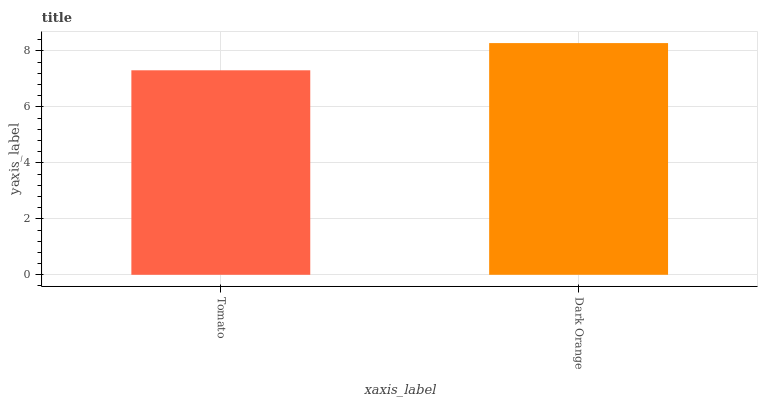Is Tomato the minimum?
Answer yes or no. Yes. Is Dark Orange the maximum?
Answer yes or no. Yes. Is Dark Orange the minimum?
Answer yes or no. No. Is Dark Orange greater than Tomato?
Answer yes or no. Yes. Is Tomato less than Dark Orange?
Answer yes or no. Yes. Is Tomato greater than Dark Orange?
Answer yes or no. No. Is Dark Orange less than Tomato?
Answer yes or no. No. Is Dark Orange the high median?
Answer yes or no. Yes. Is Tomato the low median?
Answer yes or no. Yes. Is Tomato the high median?
Answer yes or no. No. Is Dark Orange the low median?
Answer yes or no. No. 